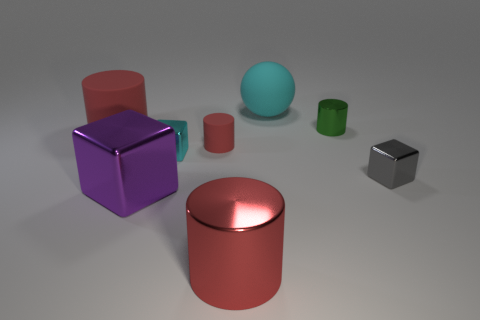How does the lighting in the image affect the appearance of the objects? The lighting in the image creates subtle shadows and highlights that reveal the textures and contours of the objects. The reflective properties of the materials are also enhanced, contributing to the overall depth and realism of the scene. Which object appears to be the heaviest based on its appearance? Judging from the image, the purple cube looks to be the heaviest. Its size, solid color, and lack of translucency suggest a dense and possibly metallic material, which usually indicates a greater weight. 